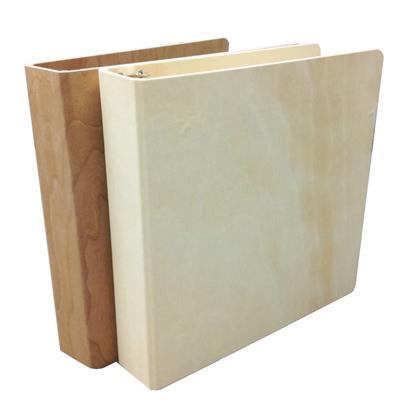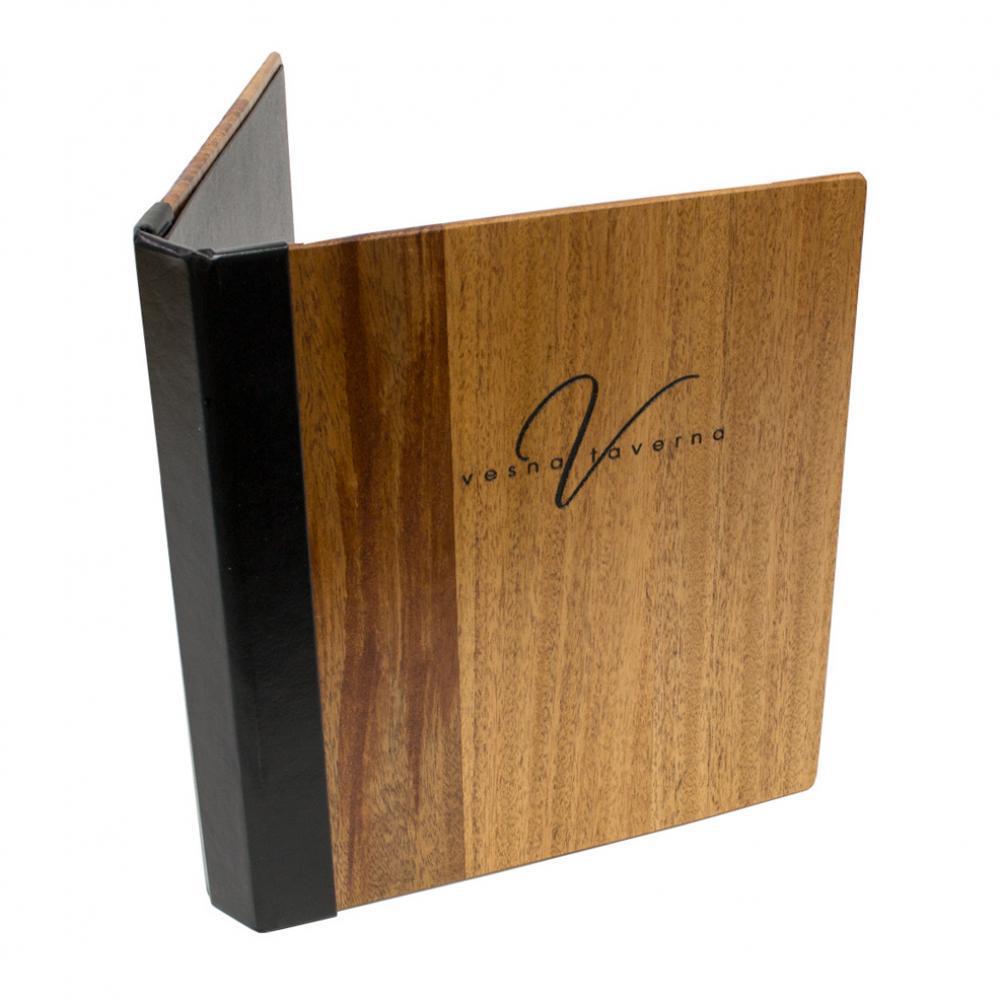The first image is the image on the left, the second image is the image on the right. Considering the images on both sides, is "There are at least three binders." valid? Answer yes or no. Yes. The first image is the image on the left, the second image is the image on the right. For the images shown, is this caption "One of the binders is solid blue." true? Answer yes or no. No. 